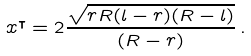Convert formula to latex. <formula><loc_0><loc_0><loc_500><loc_500>x ^ { \intercal } = 2 \frac { \sqrt { r R ( l - r ) ( R - l ) } } { ( R - r ) } \, .</formula> 